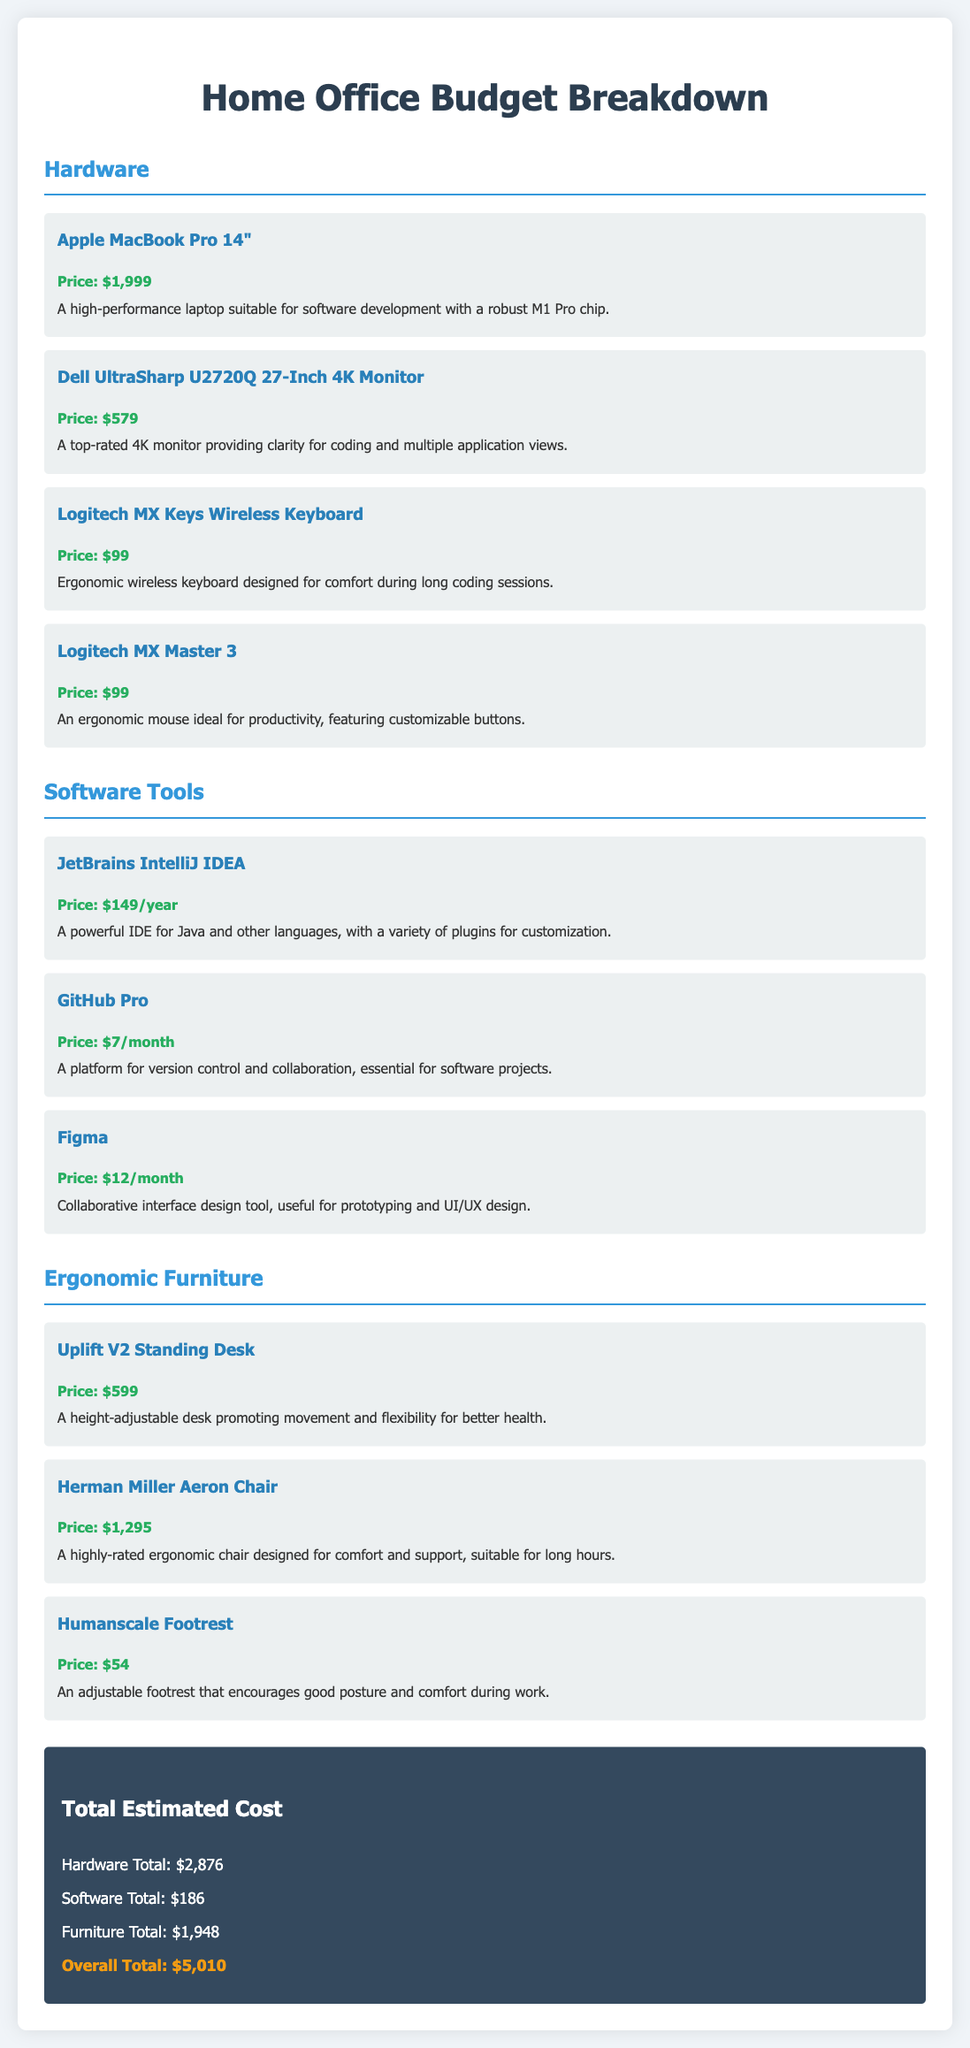what is the price of the Apple MacBook Pro 14"? The document states the price of the Apple MacBook Pro 14" is listed individually.
Answer: $1,999 how much does the JetBrains IntelliJ IDEA cost per year? The document specifies the annual cost for JetBrains IntelliJ IDEA under software tools.
Answer: $149/year what is the total estimated cost for furniture? The document provides specific totals for each category, including furniture.
Answer: $1,948 which ergonomic chair is mentioned in the budget? The budget lists a specific ergonomic chair designed for long hours.
Answer: Herman Miller Aeron Chair what is the overall total for the home office setup? The document presents a summary of all costs, culminating in the overall total.
Answer: $5,010 how much does GitHub Pro cost per month? The document indicates the monthly fee for GitHub Pro in the software tools section.
Answer: $7/month what type of standing desk is included in the budget? The document specifies the model of the standing desk as part of the ergonomic furniture section.
Answer: Uplift V2 Standing Desk how many monitors are listed in the hardware section? The document enumerates all hardware items, including the number of monitors.
Answer: 1 